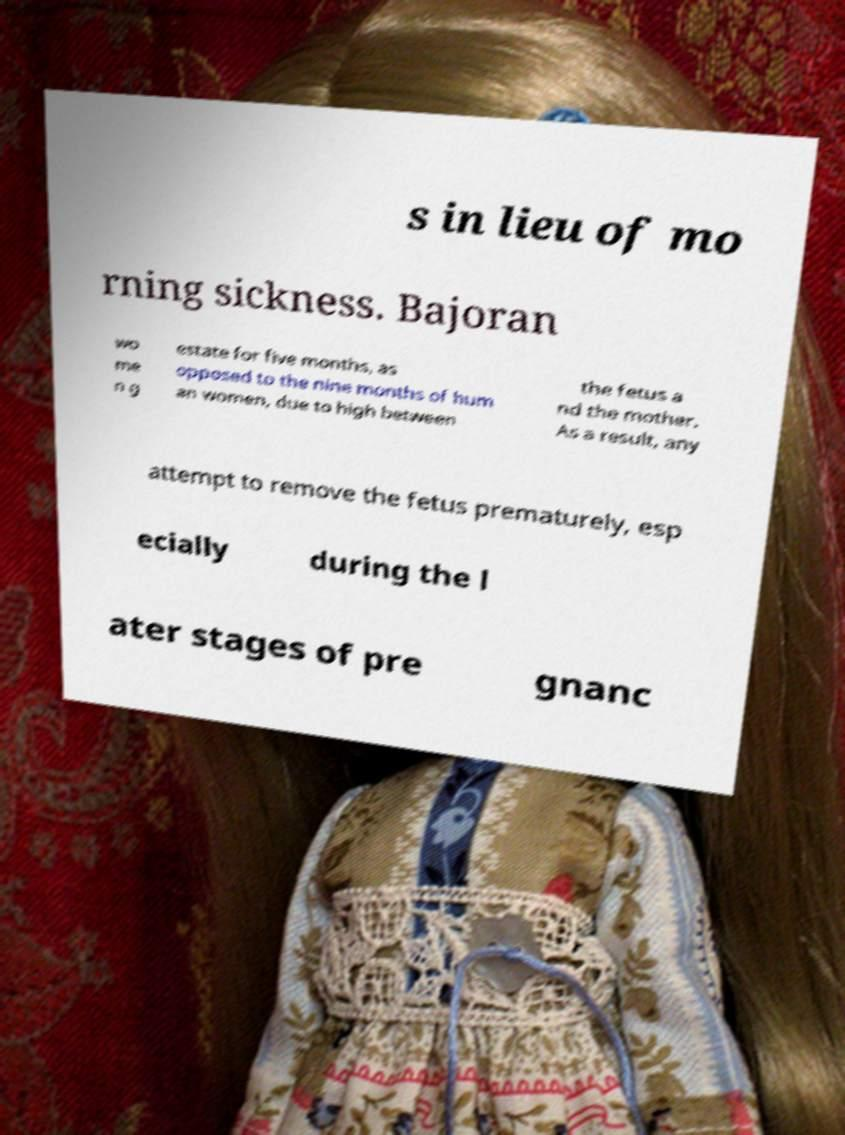What messages or text are displayed in this image? I need them in a readable, typed format. s in lieu of mo rning sickness. Bajoran wo me n g estate for five months, as opposed to the nine months of hum an women, due to high between the fetus a nd the mother. As a result, any attempt to remove the fetus prematurely, esp ecially during the l ater stages of pre gnanc 